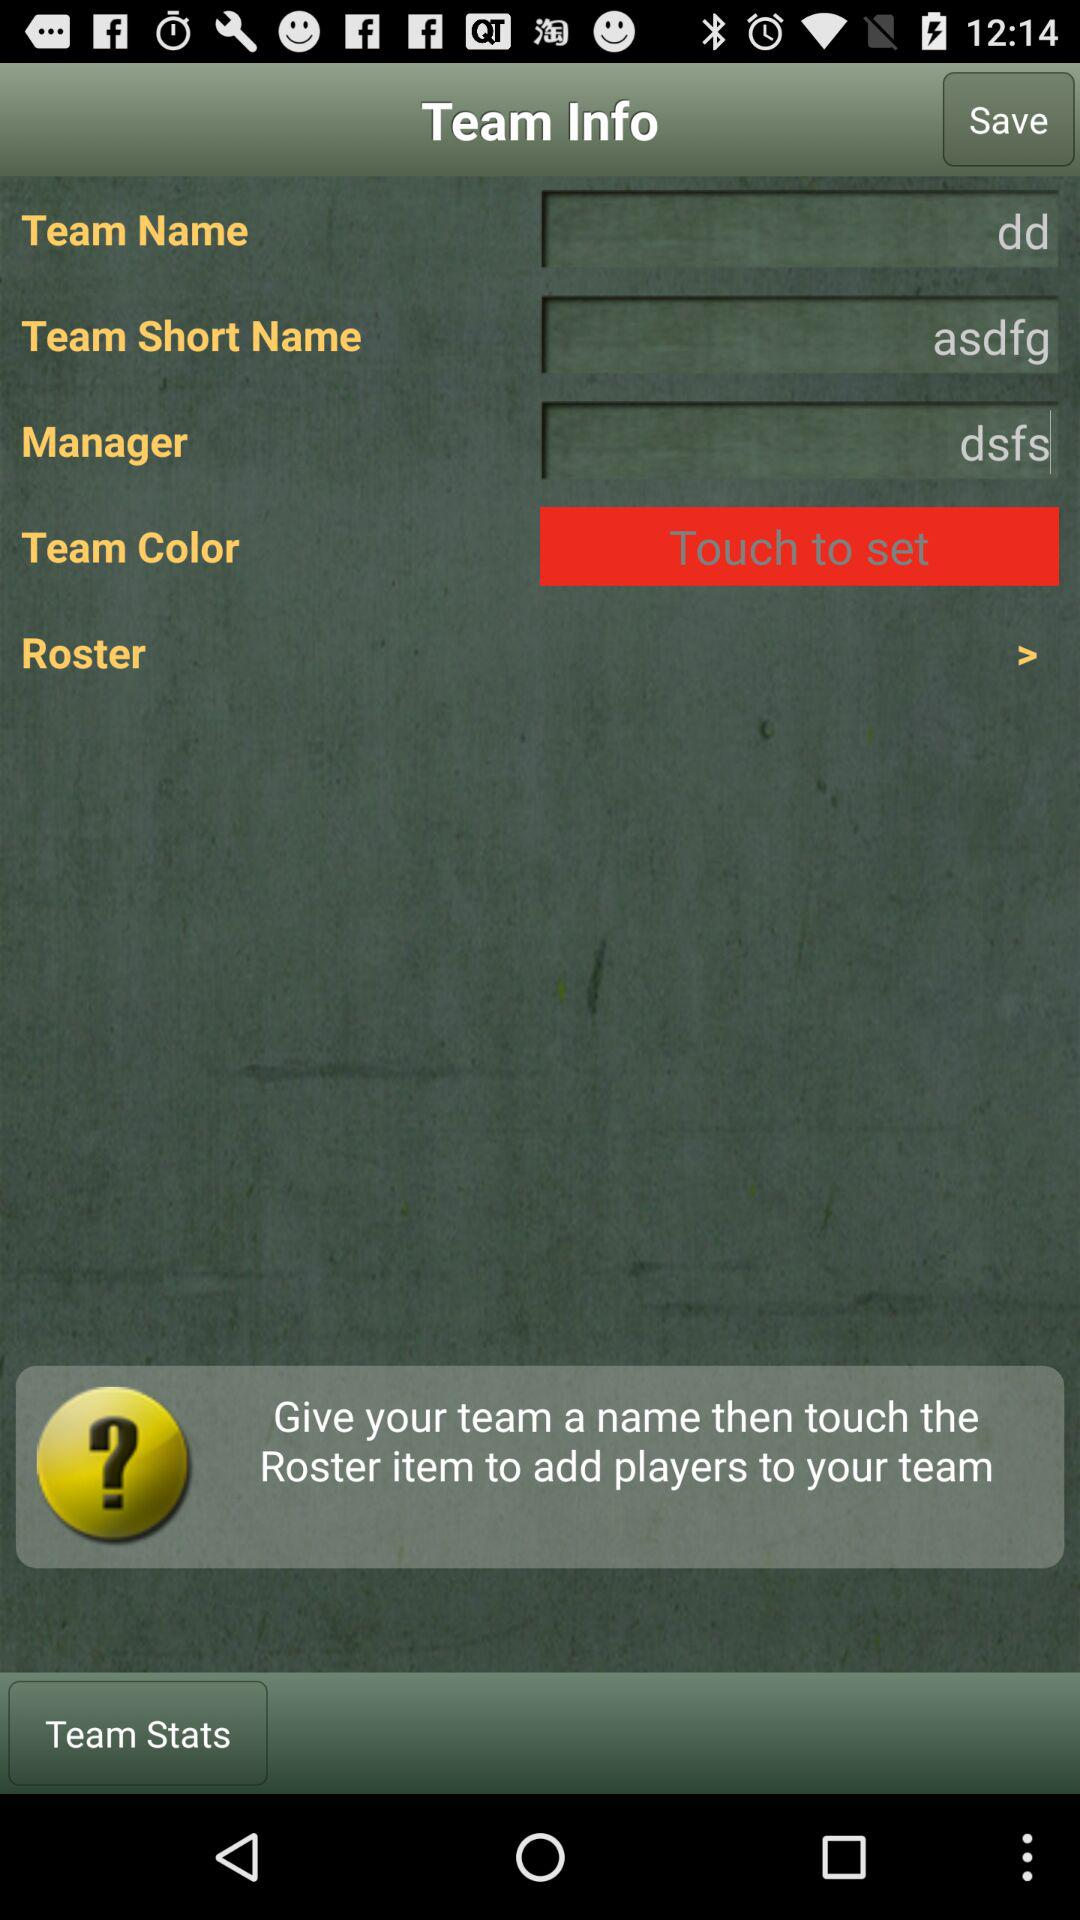What is the team color?
When the provided information is insufficient, respond with <no answer>. <no answer> 